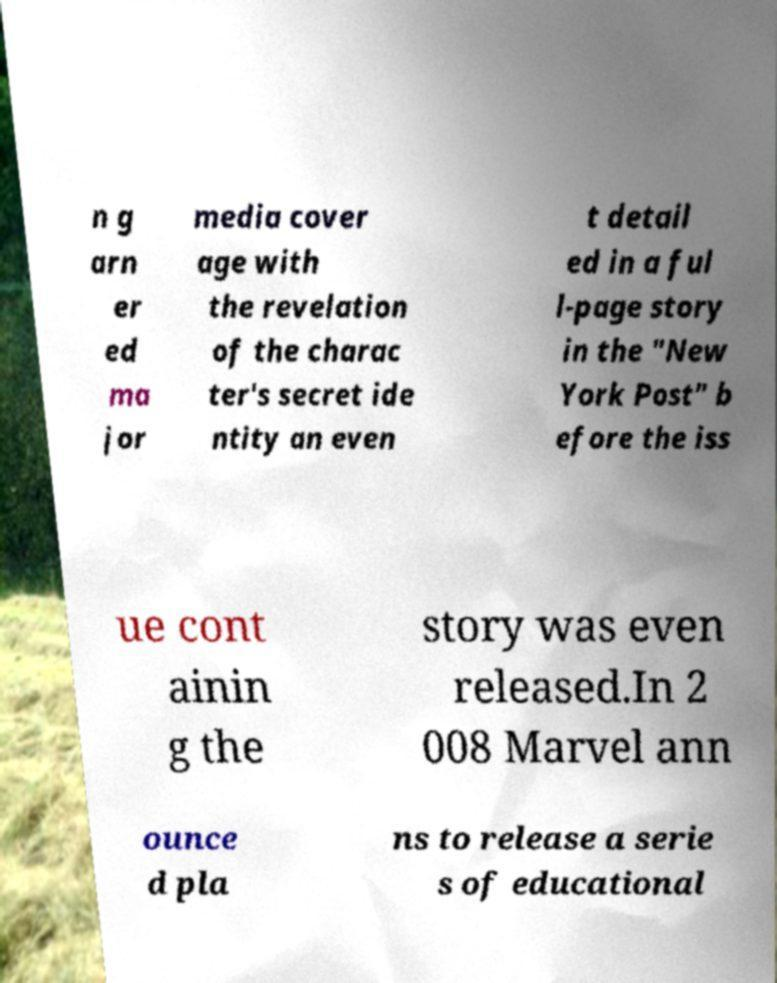Could you extract and type out the text from this image? n g arn er ed ma jor media cover age with the revelation of the charac ter's secret ide ntity an even t detail ed in a ful l-page story in the "New York Post" b efore the iss ue cont ainin g the story was even released.In 2 008 Marvel ann ounce d pla ns to release a serie s of educational 